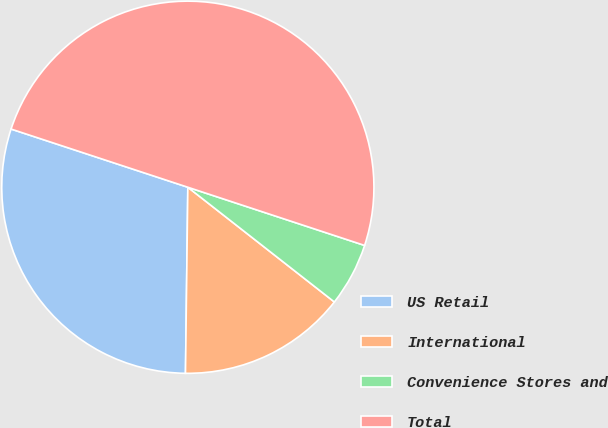<chart> <loc_0><loc_0><loc_500><loc_500><pie_chart><fcel>US Retail<fcel>International<fcel>Convenience Stores and<fcel>Total<nl><fcel>29.86%<fcel>14.63%<fcel>5.51%<fcel>50.0%<nl></chart> 